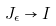<formula> <loc_0><loc_0><loc_500><loc_500>J _ { \epsilon } \to I</formula> 